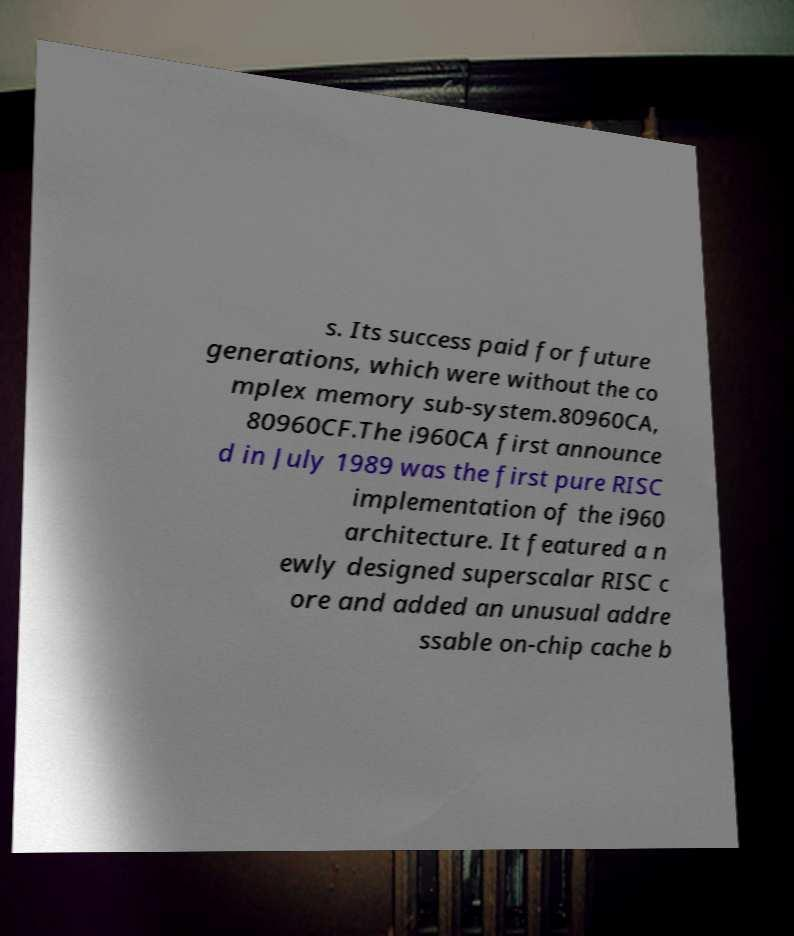Please read and relay the text visible in this image. What does it say? s. Its success paid for future generations, which were without the co mplex memory sub-system.80960CA, 80960CF.The i960CA first announce d in July 1989 was the first pure RISC implementation of the i960 architecture. It featured a n ewly designed superscalar RISC c ore and added an unusual addre ssable on-chip cache b 